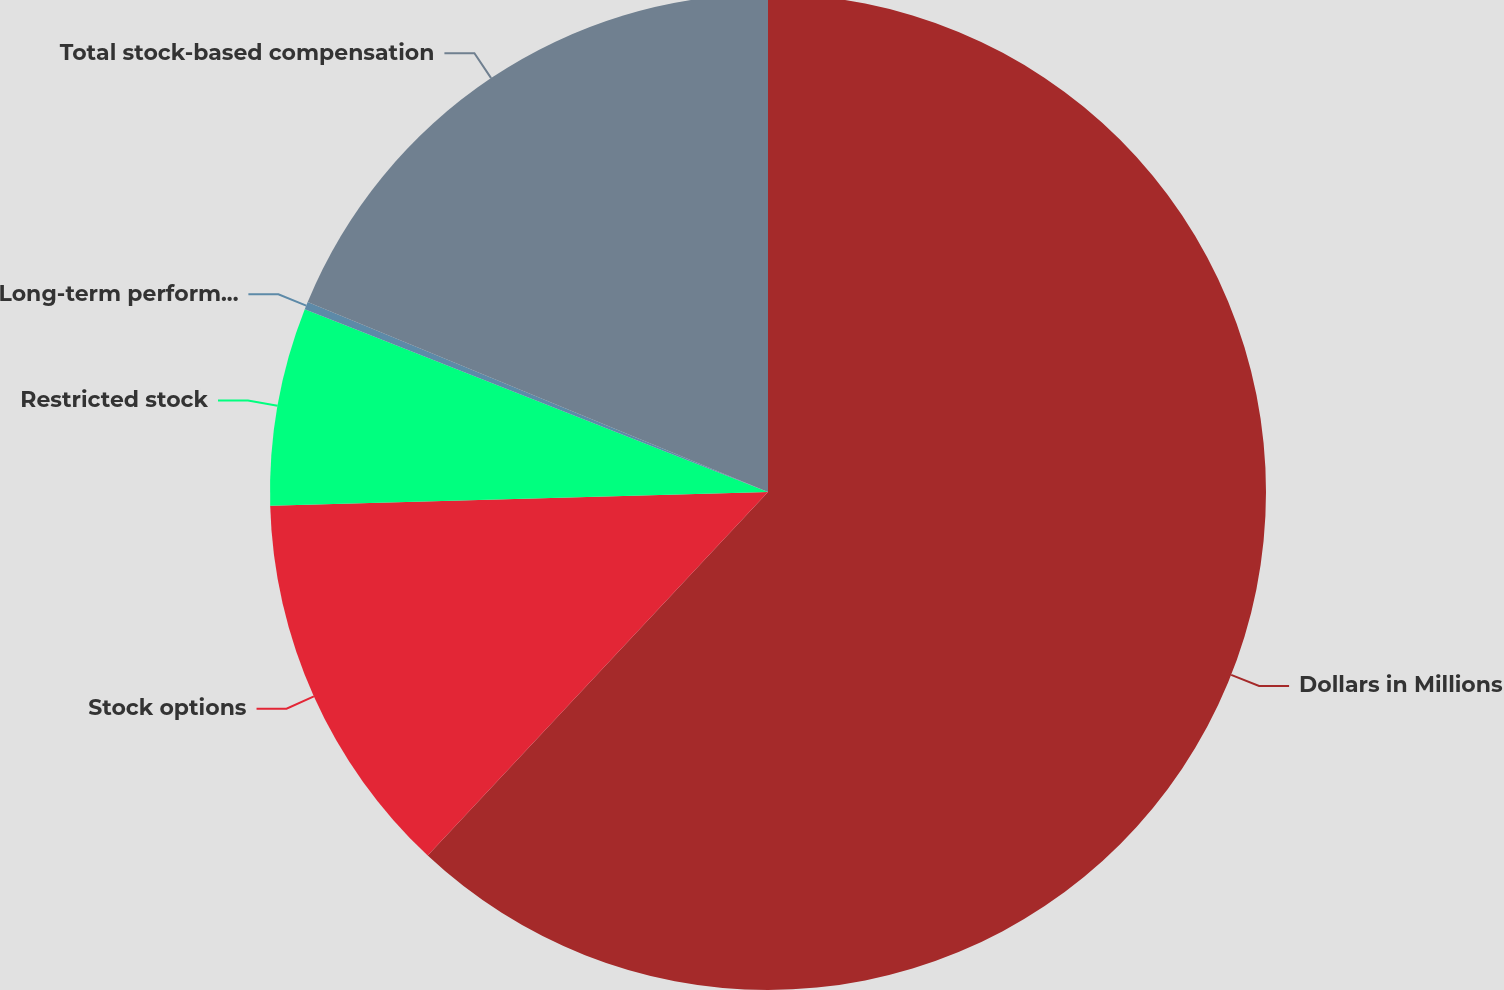<chart> <loc_0><loc_0><loc_500><loc_500><pie_chart><fcel>Dollars in Millions<fcel>Stock options<fcel>Restricted stock<fcel>Long-term performance shares<fcel>Total stock-based compensation<nl><fcel>61.98%<fcel>12.59%<fcel>6.42%<fcel>0.25%<fcel>18.77%<nl></chart> 